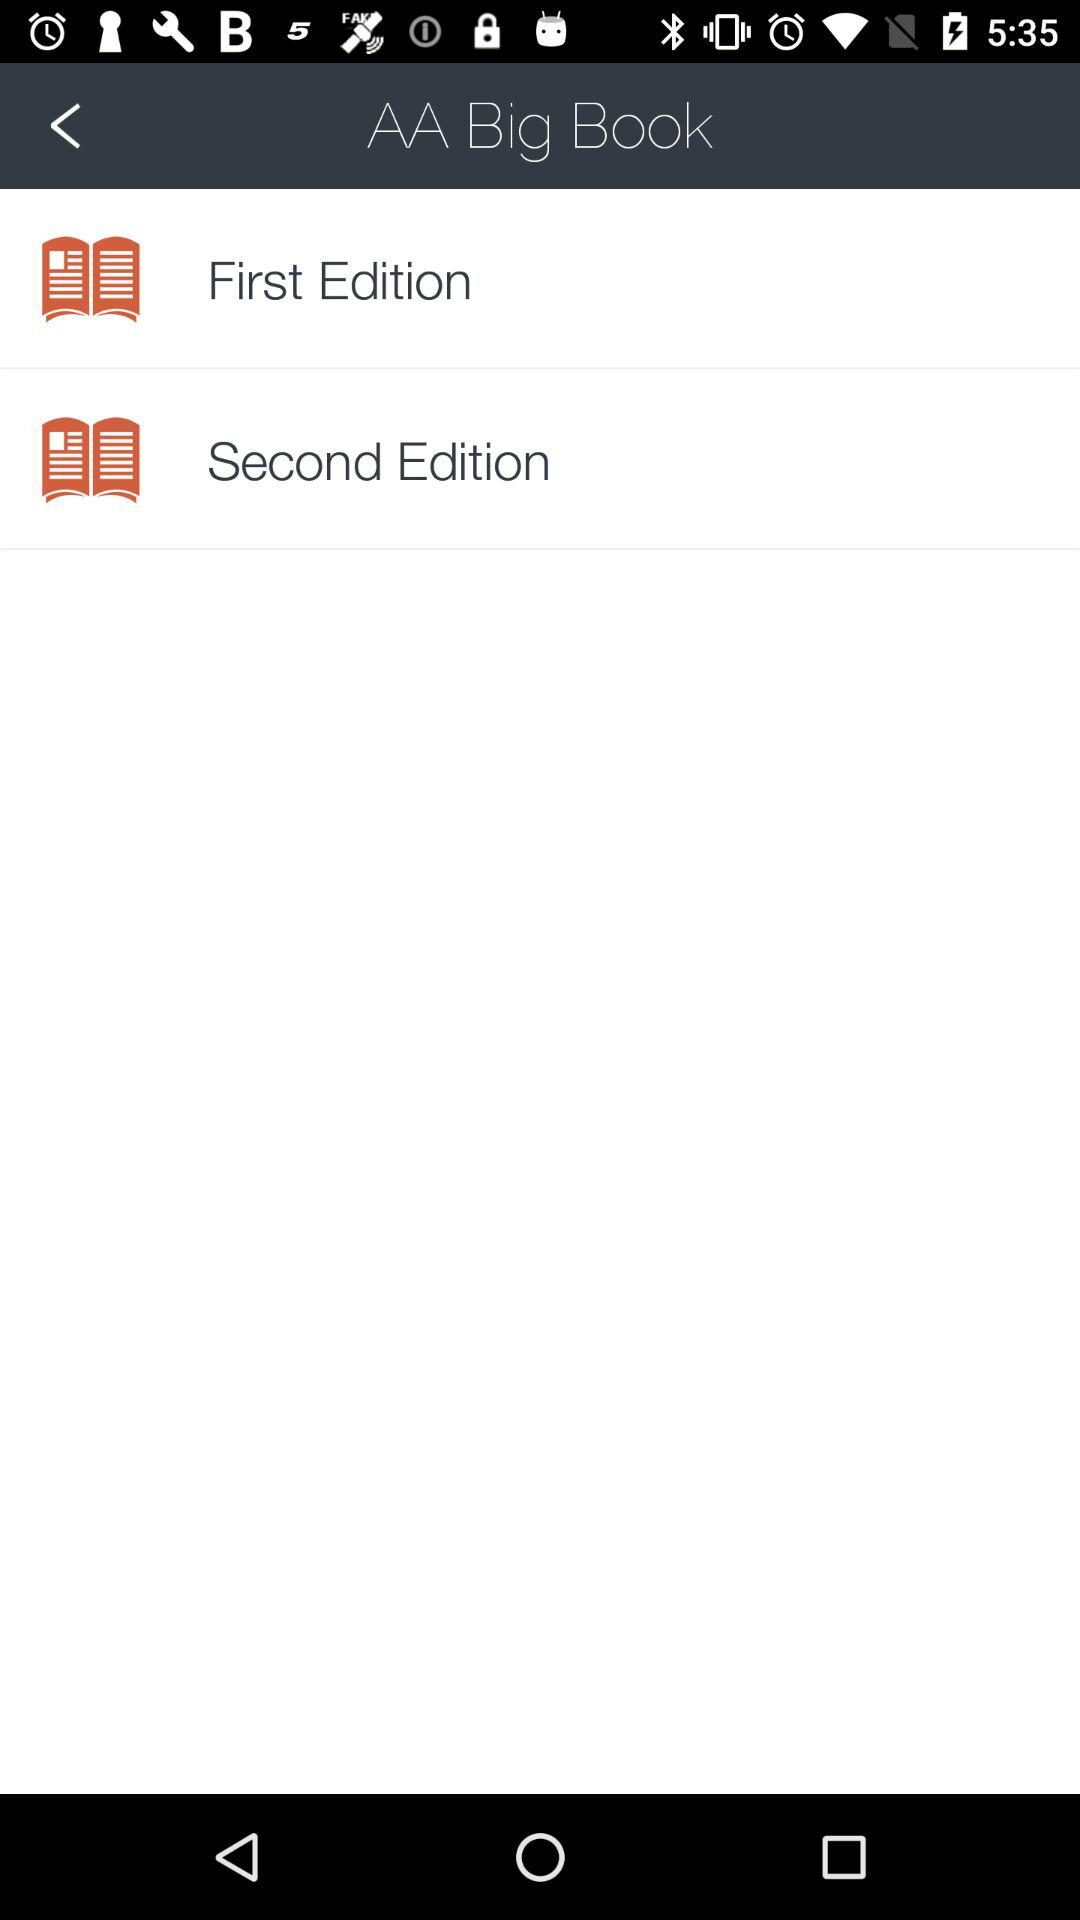Which editions are given? The given editions are the first and second. 